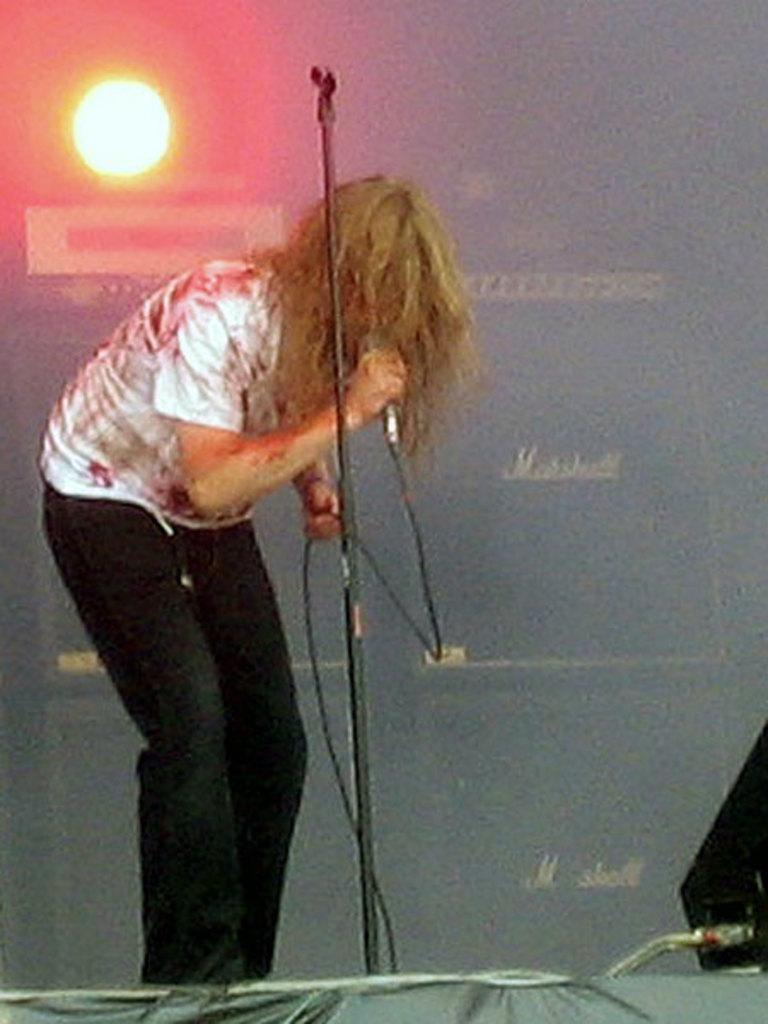What is the person in the image doing? The person is holding a microphone. What object can be seen near the person? There is a stand in the image. What is located on the right side of the image? There is a loudspeaker on the right side of the image. What can be seen in the background of the image? There is a light and text in the background of the image. How does the person in the image increase their dad's power? There is no mention of a dad or power in the image, and the person is simply holding a microphone. 